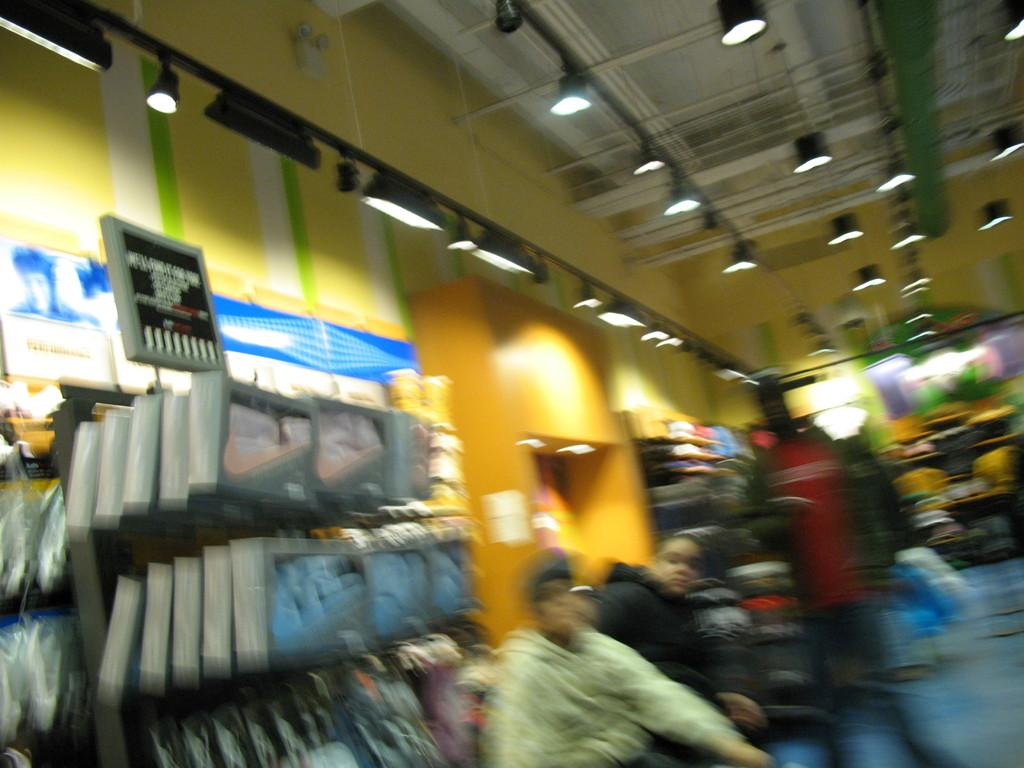Who or what can be seen in the image? There are people in the image. What objects are present in the image? There are boards, lights, and some unspecified objects in the image. What type of structure is visible in the image? There is a wall in the image. How does the trail lead to the adjustment of the fact in the image? There is no trail, adjustment, or fact present in the image. 